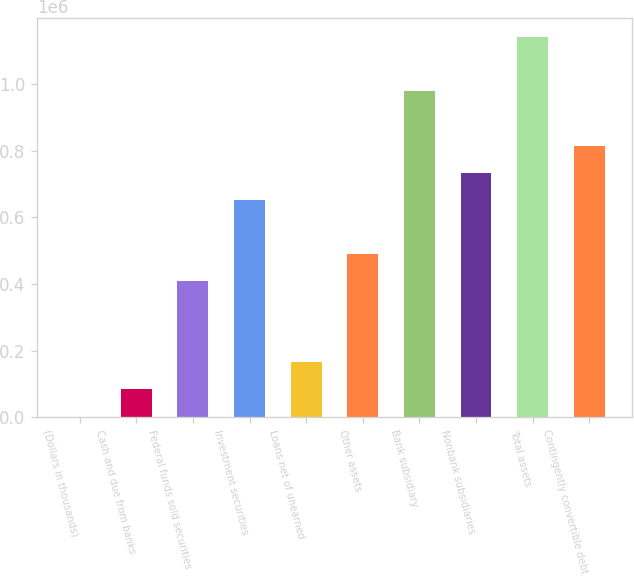Convert chart to OTSL. <chart><loc_0><loc_0><loc_500><loc_500><bar_chart><fcel>(Dollars in thousands)<fcel>Cash and due from banks<fcel>Federal funds sold securities<fcel>Investment securities<fcel>Loans net of unearned<fcel>Other assets<fcel>Bank subsidiary<fcel>Nonbank subsidiaries<fcel>Total assets<fcel>Contingently convertible debt<nl><fcel>2005<fcel>83282.2<fcel>408391<fcel>652223<fcel>164559<fcel>489668<fcel>977331<fcel>733500<fcel>1.13989e+06<fcel>814777<nl></chart> 